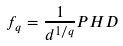Convert formula to latex. <formula><loc_0><loc_0><loc_500><loc_500>f _ { q } = \frac { 1 } { d ^ { 1 / q } } P H D</formula> 